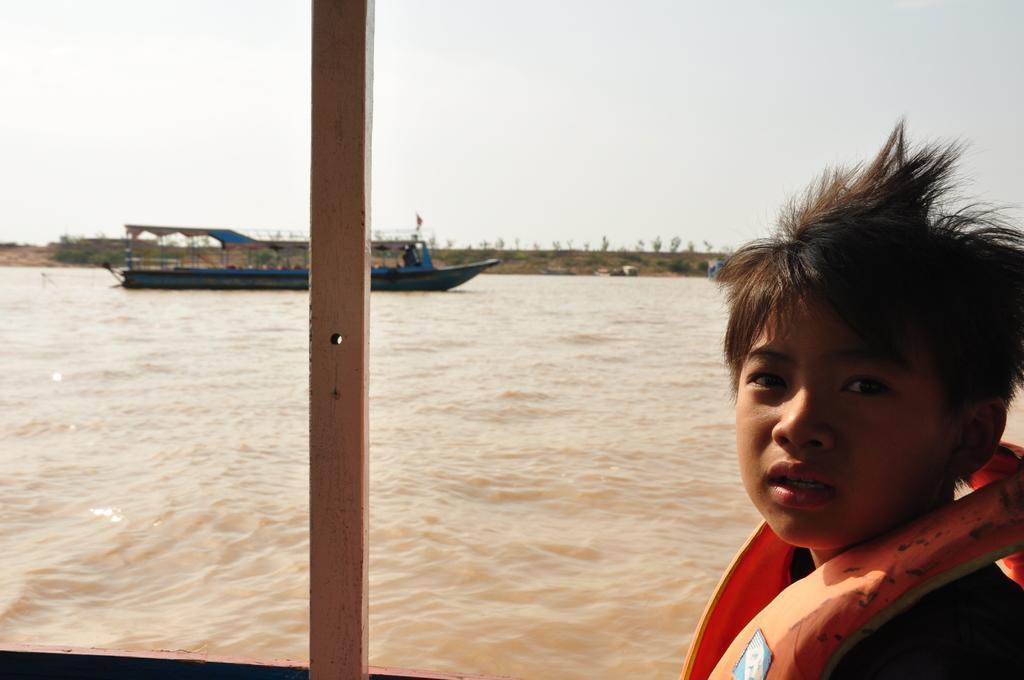Could you give a brief overview of what you see in this image? At the bottom of the image there is a boy standing and watching. Behind him there is water, above the water there is a ship. At the top of the image there is sky. 